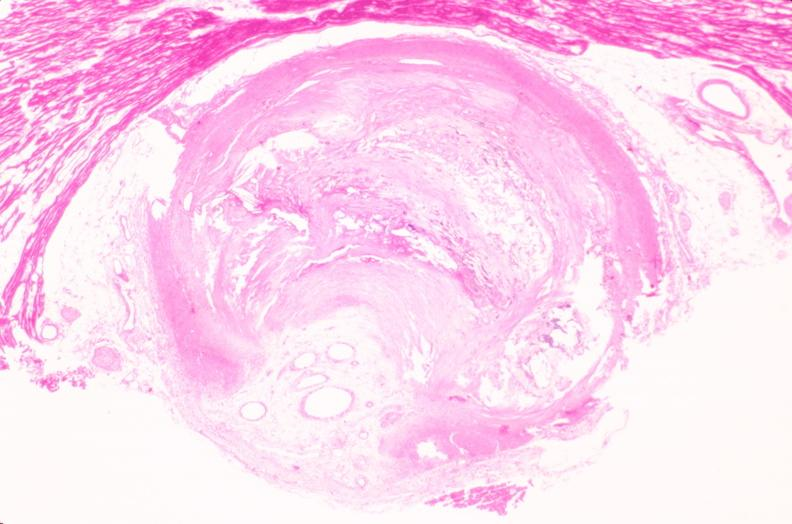s peritoneal fluid present?
Answer the question using a single word or phrase. No 